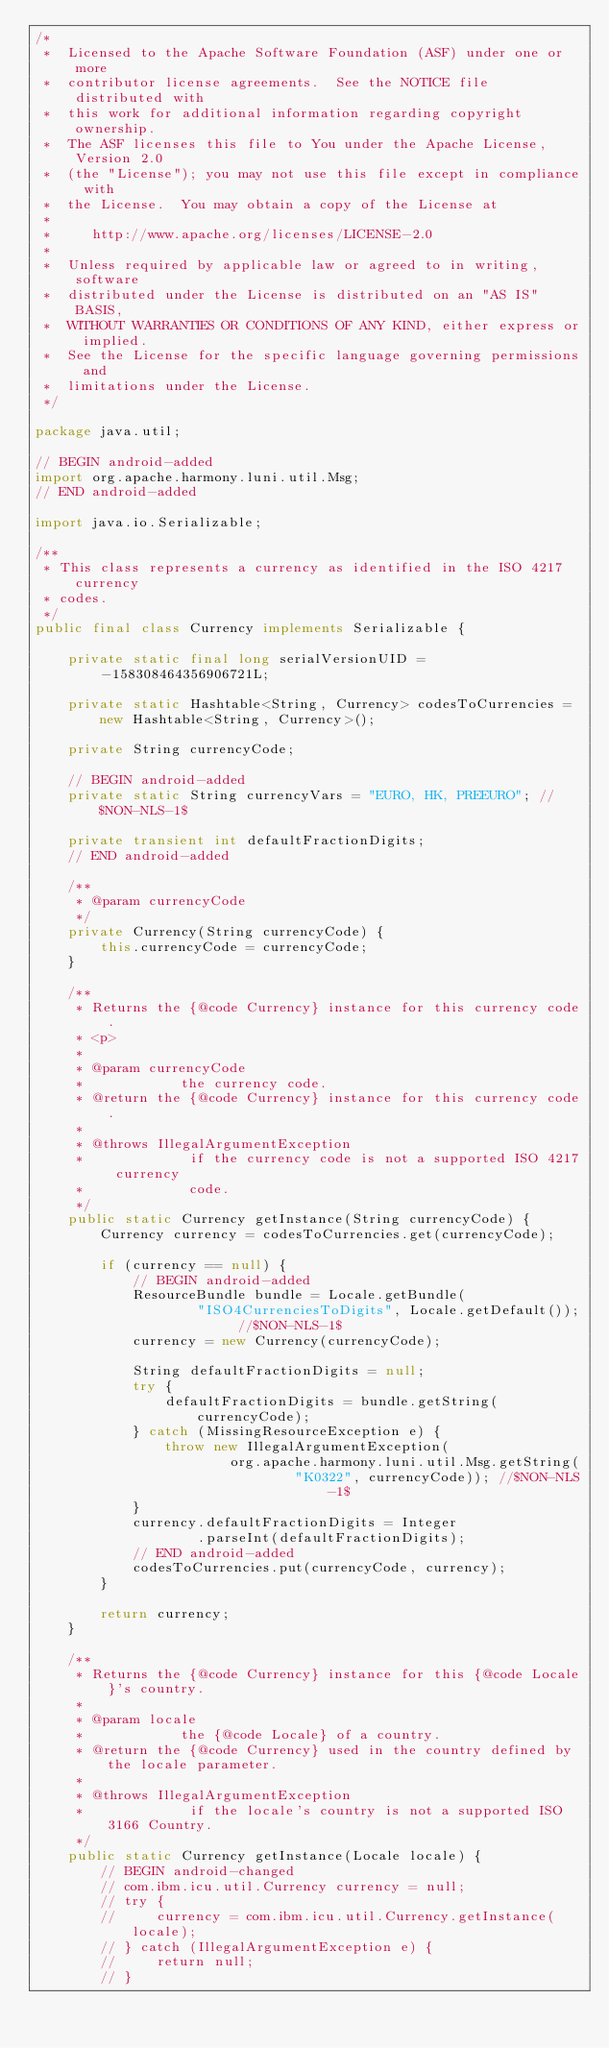<code> <loc_0><loc_0><loc_500><loc_500><_Java_>/*
 *  Licensed to the Apache Software Foundation (ASF) under one or more
 *  contributor license agreements.  See the NOTICE file distributed with
 *  this work for additional information regarding copyright ownership.
 *  The ASF licenses this file to You under the Apache License, Version 2.0
 *  (the "License"); you may not use this file except in compliance with
 *  the License.  You may obtain a copy of the License at
 *
 *     http://www.apache.org/licenses/LICENSE-2.0
 *
 *  Unless required by applicable law or agreed to in writing, software
 *  distributed under the License is distributed on an "AS IS" BASIS,
 *  WITHOUT WARRANTIES OR CONDITIONS OF ANY KIND, either express or implied.
 *  See the License for the specific language governing permissions and
 *  limitations under the License.
 */

package java.util;

// BEGIN android-added
import org.apache.harmony.luni.util.Msg;
// END android-added

import java.io.Serializable;

/**
 * This class represents a currency as identified in the ISO 4217 currency
 * codes.
 */
public final class Currency implements Serializable {

    private static final long serialVersionUID = -158308464356906721L;

    private static Hashtable<String, Currency> codesToCurrencies = new Hashtable<String, Currency>();

    private String currencyCode;

    // BEGIN android-added
    private static String currencyVars = "EURO, HK, PREEURO"; //$NON-NLS-1$

    private transient int defaultFractionDigits;
    // END android-added

    /**
     * @param currencyCode
     */
    private Currency(String currencyCode) {
        this.currencyCode = currencyCode;
    }

    /**
     * Returns the {@code Currency} instance for this currency code.
     * <p>
     *
     * @param currencyCode
     *            the currency code.
     * @return the {@code Currency} instance for this currency code.
     *
     * @throws IllegalArgumentException
     *             if the currency code is not a supported ISO 4217 currency
     *             code.
     */
    public static Currency getInstance(String currencyCode) {
        Currency currency = codesToCurrencies.get(currencyCode);

        if (currency == null) {
            // BEGIN android-added
            ResourceBundle bundle = Locale.getBundle(
                    "ISO4CurrenciesToDigits", Locale.getDefault()); //$NON-NLS-1$
            currency = new Currency(currencyCode);

            String defaultFractionDigits = null;
            try {
                defaultFractionDigits = bundle.getString(currencyCode);
            } catch (MissingResourceException e) {
                throw new IllegalArgumentException(
                        org.apache.harmony.luni.util.Msg.getString(
                                "K0322", currencyCode)); //$NON-NLS-1$
            }
            currency.defaultFractionDigits = Integer
                    .parseInt(defaultFractionDigits);
            // END android-added
            codesToCurrencies.put(currencyCode, currency);
        }

        return currency;
    }

    /**
     * Returns the {@code Currency} instance for this {@code Locale}'s country.
     *
     * @param locale
     *            the {@code Locale} of a country.
     * @return the {@code Currency} used in the country defined by the locale parameter.
     *
     * @throws IllegalArgumentException
     *             if the locale's country is not a supported ISO 3166 Country.
     */
    public static Currency getInstance(Locale locale) {
        // BEGIN android-changed
        // com.ibm.icu.util.Currency currency = null;
        // try {
        //     currency = com.ibm.icu.util.Currency.getInstance(locale);
        // } catch (IllegalArgumentException e) {
        //     return null;
        // }</code> 